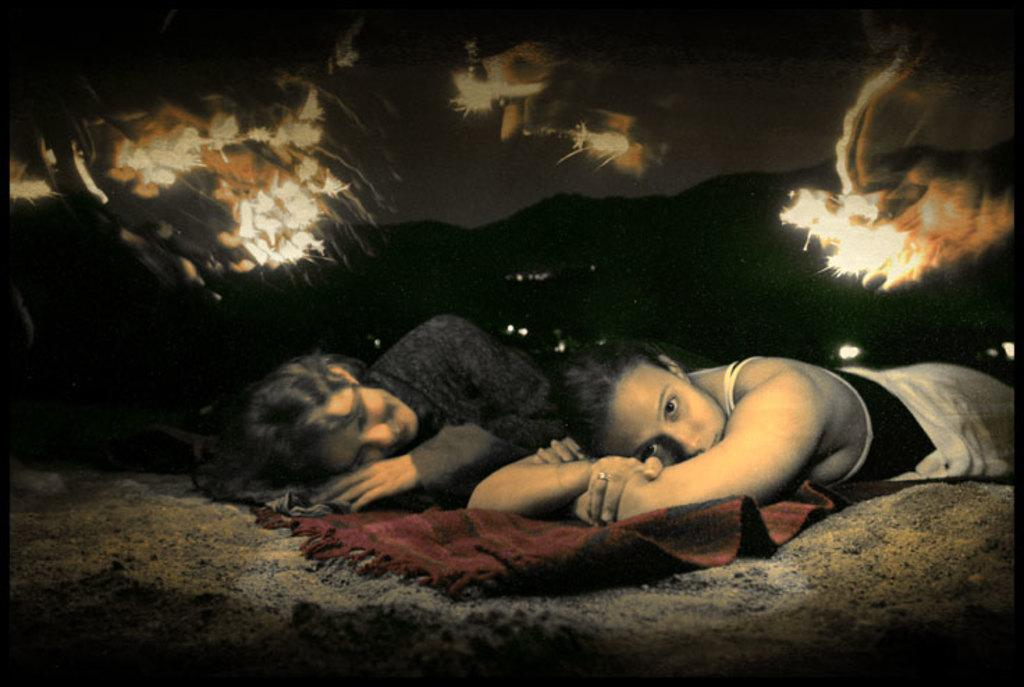What are the two ladies in the image doing? The two ladies are sleeping on the floor. What color is the carpet in the image? The carpet in the image is red. What can be seen in the background of the image? There are mountains in the background of the image. Has the image been altered in any way? Yes, the image has been edited. Are there any cobwebs visible in the image? There are no cobwebs present in the image. 